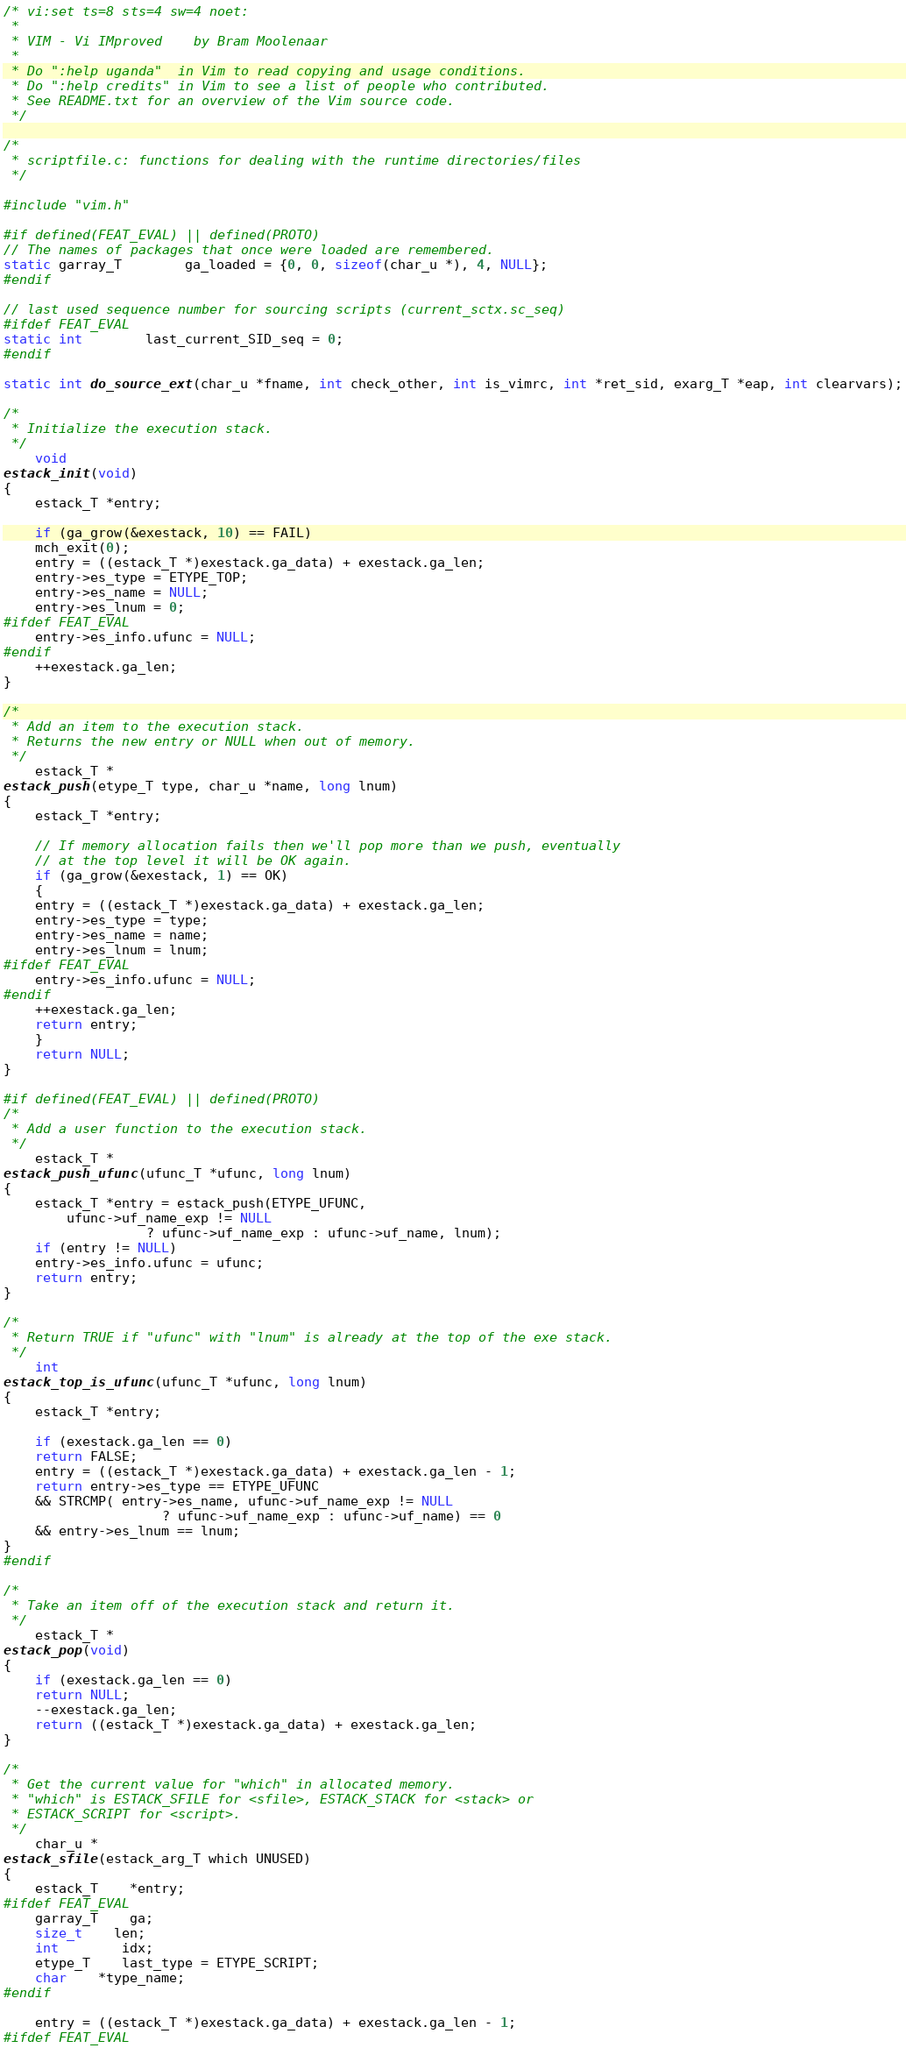Convert code to text. <code><loc_0><loc_0><loc_500><loc_500><_C_>/* vi:set ts=8 sts=4 sw=4 noet:
 *
 * VIM - Vi IMproved	by Bram Moolenaar
 *
 * Do ":help uganda"  in Vim to read copying and usage conditions.
 * Do ":help credits" in Vim to see a list of people who contributed.
 * See README.txt for an overview of the Vim source code.
 */

/*
 * scriptfile.c: functions for dealing with the runtime directories/files
 */

#include "vim.h"

#if defined(FEAT_EVAL) || defined(PROTO)
// The names of packages that once were loaded are remembered.
static garray_T		ga_loaded = {0, 0, sizeof(char_u *), 4, NULL};
#endif

// last used sequence number for sourcing scripts (current_sctx.sc_seq)
#ifdef FEAT_EVAL
static int		last_current_SID_seq = 0;
#endif

static int do_source_ext(char_u *fname, int check_other, int is_vimrc, int *ret_sid, exarg_T *eap, int clearvars);

/*
 * Initialize the execution stack.
 */
    void
estack_init(void)
{
    estack_T *entry;

    if (ga_grow(&exestack, 10) == FAIL)
	mch_exit(0);
    entry = ((estack_T *)exestack.ga_data) + exestack.ga_len;
    entry->es_type = ETYPE_TOP;
    entry->es_name = NULL;
    entry->es_lnum = 0;
#ifdef FEAT_EVAL
    entry->es_info.ufunc = NULL;
#endif
    ++exestack.ga_len;
}

/*
 * Add an item to the execution stack.
 * Returns the new entry or NULL when out of memory.
 */
    estack_T *
estack_push(etype_T type, char_u *name, long lnum)
{
    estack_T *entry;

    // If memory allocation fails then we'll pop more than we push, eventually
    // at the top level it will be OK again.
    if (ga_grow(&exestack, 1) == OK)
    {
	entry = ((estack_T *)exestack.ga_data) + exestack.ga_len;
	entry->es_type = type;
	entry->es_name = name;
	entry->es_lnum = lnum;
#ifdef FEAT_EVAL
	entry->es_info.ufunc = NULL;
#endif
	++exestack.ga_len;
	return entry;
    }
    return NULL;
}

#if defined(FEAT_EVAL) || defined(PROTO)
/*
 * Add a user function to the execution stack.
 */
    estack_T *
estack_push_ufunc(ufunc_T *ufunc, long lnum)
{
    estack_T *entry = estack_push(ETYPE_UFUNC,
	    ufunc->uf_name_exp != NULL
				  ? ufunc->uf_name_exp : ufunc->uf_name, lnum);
    if (entry != NULL)
	entry->es_info.ufunc = ufunc;
    return entry;
}

/*
 * Return TRUE if "ufunc" with "lnum" is already at the top of the exe stack.
 */
    int
estack_top_is_ufunc(ufunc_T *ufunc, long lnum)
{
    estack_T *entry;

    if (exestack.ga_len == 0)
	return FALSE;
    entry = ((estack_T *)exestack.ga_data) + exestack.ga_len - 1;
    return entry->es_type == ETYPE_UFUNC
	&& STRCMP( entry->es_name, ufunc->uf_name_exp != NULL
				    ? ufunc->uf_name_exp : ufunc->uf_name) == 0
	&& entry->es_lnum == lnum;
}
#endif

/*
 * Take an item off of the execution stack and return it.
 */
    estack_T *
estack_pop(void)
{
    if (exestack.ga_len == 0)
	return NULL;
    --exestack.ga_len;
    return ((estack_T *)exestack.ga_data) + exestack.ga_len;
}

/*
 * Get the current value for "which" in allocated memory.
 * "which" is ESTACK_SFILE for <sfile>, ESTACK_STACK for <stack> or
 * ESTACK_SCRIPT for <script>.
 */
    char_u *
estack_sfile(estack_arg_T which UNUSED)
{
    estack_T	*entry;
#ifdef FEAT_EVAL
    garray_T	ga;
    size_t	len;
    int		idx;
    etype_T	last_type = ETYPE_SCRIPT;
    char	*type_name;
#endif

    entry = ((estack_T *)exestack.ga_data) + exestack.ga_len - 1;
#ifdef FEAT_EVAL</code> 